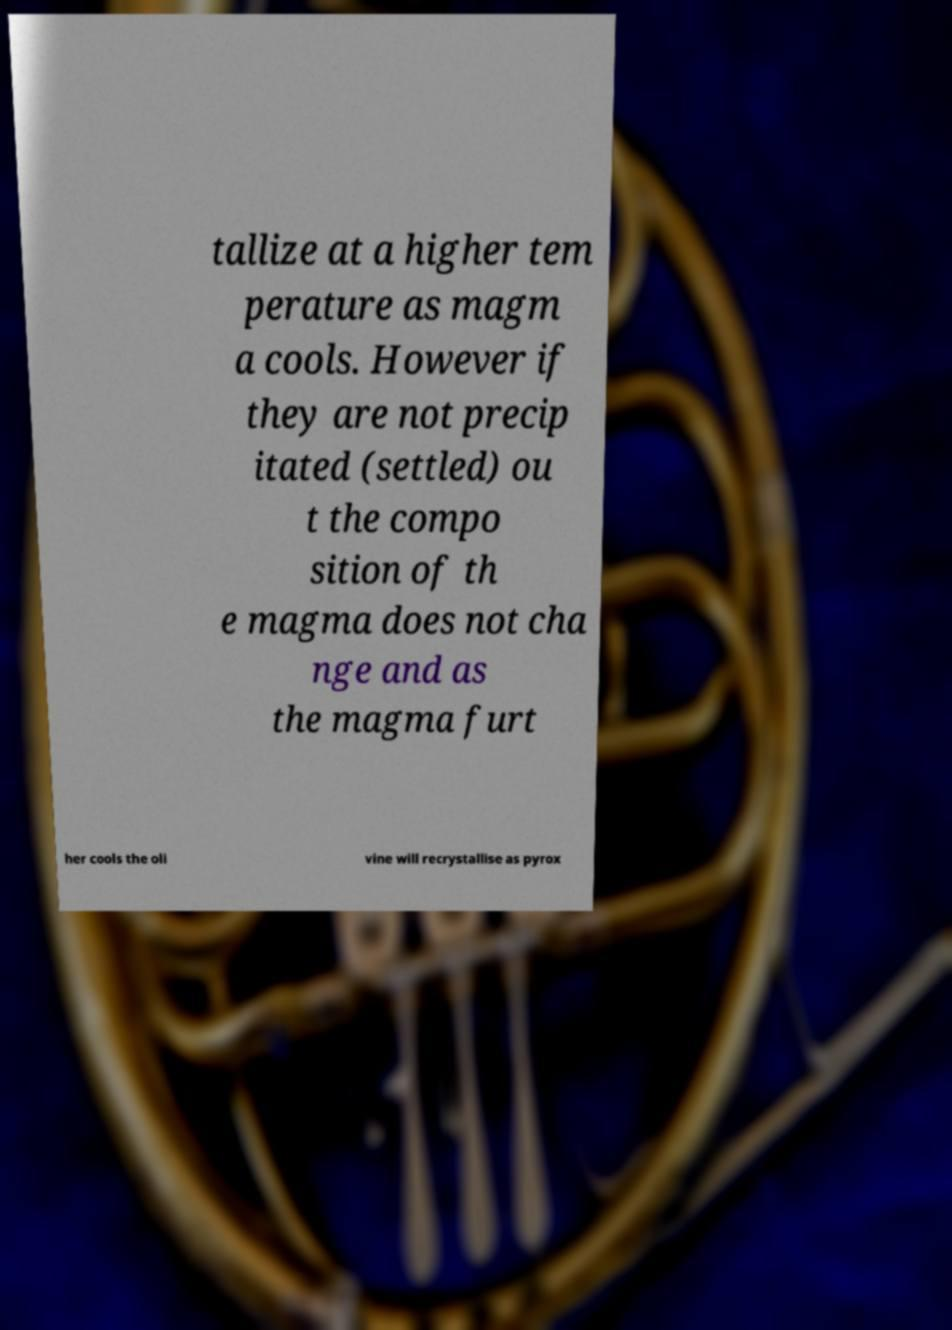For documentation purposes, I need the text within this image transcribed. Could you provide that? tallize at a higher tem perature as magm a cools. However if they are not precip itated (settled) ou t the compo sition of th e magma does not cha nge and as the magma furt her cools the oli vine will recrystallise as pyrox 